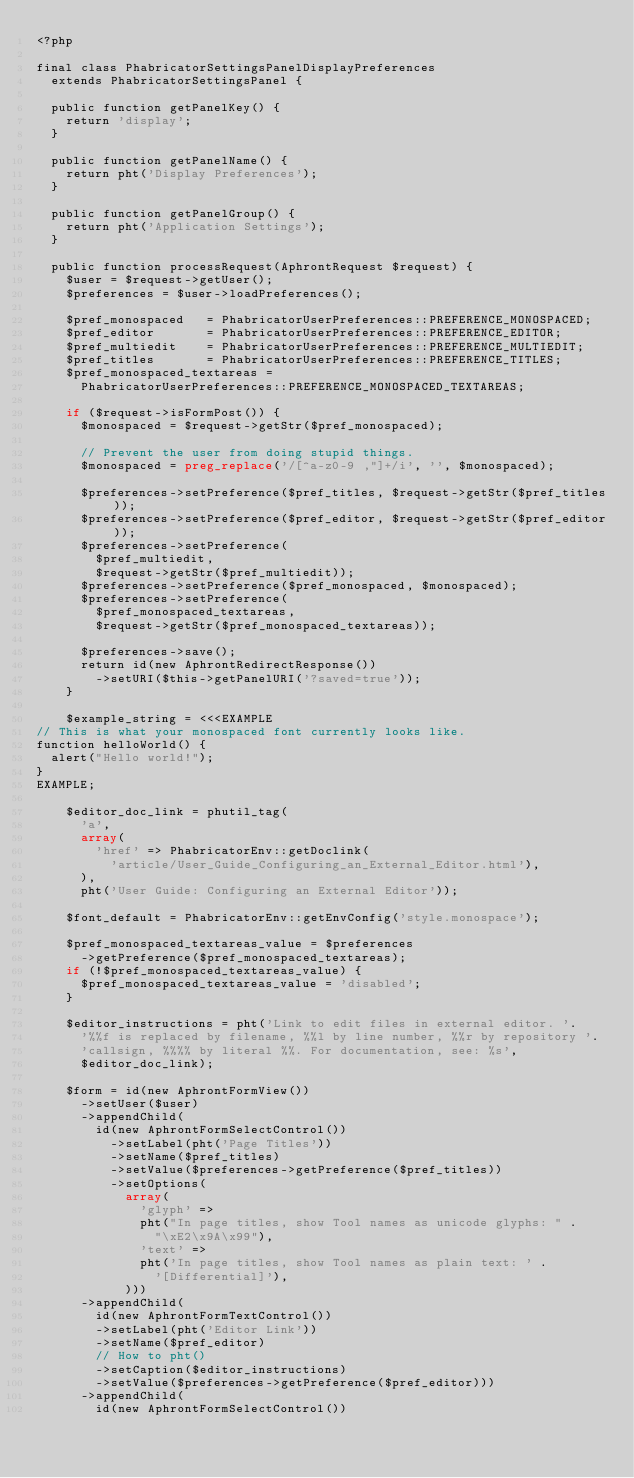Convert code to text. <code><loc_0><loc_0><loc_500><loc_500><_PHP_><?php

final class PhabricatorSettingsPanelDisplayPreferences
  extends PhabricatorSettingsPanel {

  public function getPanelKey() {
    return 'display';
  }

  public function getPanelName() {
    return pht('Display Preferences');
  }

  public function getPanelGroup() {
    return pht('Application Settings');
  }

  public function processRequest(AphrontRequest $request) {
    $user = $request->getUser();
    $preferences = $user->loadPreferences();

    $pref_monospaced   = PhabricatorUserPreferences::PREFERENCE_MONOSPACED;
    $pref_editor       = PhabricatorUserPreferences::PREFERENCE_EDITOR;
    $pref_multiedit    = PhabricatorUserPreferences::PREFERENCE_MULTIEDIT;
    $pref_titles       = PhabricatorUserPreferences::PREFERENCE_TITLES;
    $pref_monospaced_textareas =
      PhabricatorUserPreferences::PREFERENCE_MONOSPACED_TEXTAREAS;

    if ($request->isFormPost()) {
      $monospaced = $request->getStr($pref_monospaced);

      // Prevent the user from doing stupid things.
      $monospaced = preg_replace('/[^a-z0-9 ,"]+/i', '', $monospaced);

      $preferences->setPreference($pref_titles, $request->getStr($pref_titles));
      $preferences->setPreference($pref_editor, $request->getStr($pref_editor));
      $preferences->setPreference(
        $pref_multiedit,
        $request->getStr($pref_multiedit));
      $preferences->setPreference($pref_monospaced, $monospaced);
      $preferences->setPreference(
        $pref_monospaced_textareas,
        $request->getStr($pref_monospaced_textareas));

      $preferences->save();
      return id(new AphrontRedirectResponse())
        ->setURI($this->getPanelURI('?saved=true'));
    }

    $example_string = <<<EXAMPLE
// This is what your monospaced font currently looks like.
function helloWorld() {
  alert("Hello world!");
}
EXAMPLE;

    $editor_doc_link = phutil_tag(
      'a',
      array(
        'href' => PhabricatorEnv::getDoclink(
          'article/User_Guide_Configuring_an_External_Editor.html'),
      ),
      pht('User Guide: Configuring an External Editor'));

    $font_default = PhabricatorEnv::getEnvConfig('style.monospace');

    $pref_monospaced_textareas_value = $preferences
      ->getPreference($pref_monospaced_textareas);
    if (!$pref_monospaced_textareas_value) {
      $pref_monospaced_textareas_value = 'disabled';
    }

    $editor_instructions = pht('Link to edit files in external editor. '.
      '%%f is replaced by filename, %%l by line number, %%r by repository '.
      'callsign, %%%% by literal %%. For documentation, see: %s',
      $editor_doc_link);

    $form = id(new AphrontFormView())
      ->setUser($user)
      ->appendChild(
        id(new AphrontFormSelectControl())
          ->setLabel(pht('Page Titles'))
          ->setName($pref_titles)
          ->setValue($preferences->getPreference($pref_titles))
          ->setOptions(
            array(
              'glyph' =>
              pht("In page titles, show Tool names as unicode glyphs: " .
                "\xE2\x9A\x99"),
              'text' =>
              pht('In page titles, show Tool names as plain text: ' .
                '[Differential]'),
            )))
      ->appendChild(
        id(new AphrontFormTextControl())
        ->setLabel(pht('Editor Link'))
        ->setName($pref_editor)
        // How to pht()
        ->setCaption($editor_instructions)
        ->setValue($preferences->getPreference($pref_editor)))
      ->appendChild(
        id(new AphrontFormSelectControl())</code> 